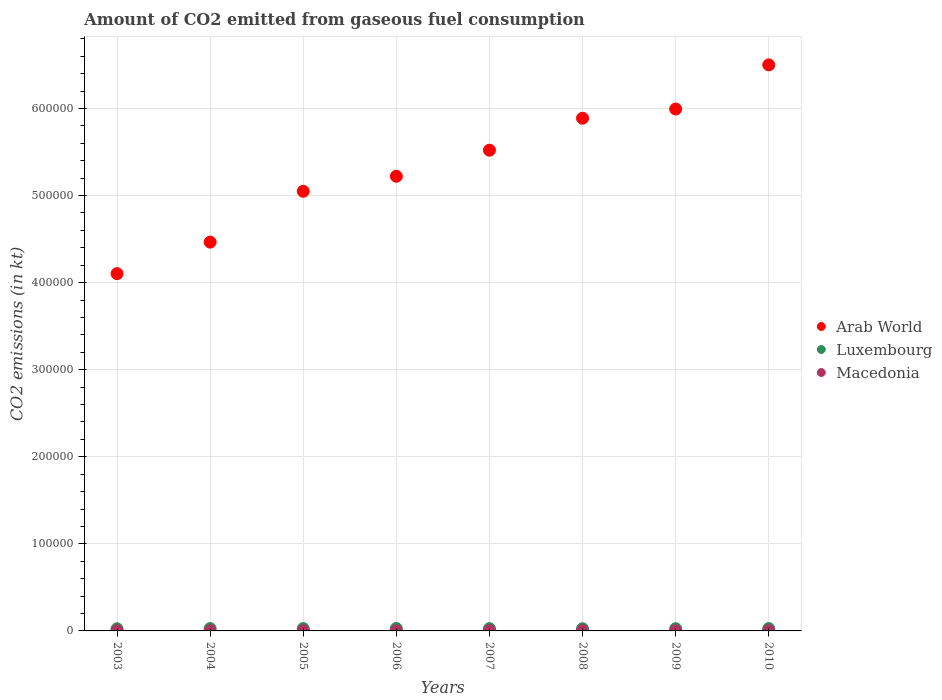How many different coloured dotlines are there?
Provide a succinct answer. 3. Is the number of dotlines equal to the number of legend labels?
Give a very brief answer. Yes. What is the amount of CO2 emitted in Arab World in 2005?
Your answer should be very brief. 5.05e+05. Across all years, what is the maximum amount of CO2 emitted in Arab World?
Your response must be concise. 6.50e+05. Across all years, what is the minimum amount of CO2 emitted in Arab World?
Keep it short and to the point. 4.10e+05. In which year was the amount of CO2 emitted in Arab World maximum?
Your answer should be very brief. 2010. What is the total amount of CO2 emitted in Arab World in the graph?
Your answer should be compact. 4.27e+06. What is the difference between the amount of CO2 emitted in Macedonia in 2006 and that in 2009?
Give a very brief answer. 7.33. What is the difference between the amount of CO2 emitted in Luxembourg in 2006 and the amount of CO2 emitted in Arab World in 2007?
Offer a terse response. -5.49e+05. What is the average amount of CO2 emitted in Arab World per year?
Keep it short and to the point. 5.34e+05. In the year 2003, what is the difference between the amount of CO2 emitted in Macedonia and amount of CO2 emitted in Luxembourg?
Give a very brief answer. -2321.21. What is the ratio of the amount of CO2 emitted in Luxembourg in 2003 to that in 2010?
Give a very brief answer. 0.9. Is the difference between the amount of CO2 emitted in Macedonia in 2004 and 2006 greater than the difference between the amount of CO2 emitted in Luxembourg in 2004 and 2006?
Make the answer very short. Yes. What is the difference between the highest and the second highest amount of CO2 emitted in Luxembourg?
Keep it short and to the point. 77.01. What is the difference between the highest and the lowest amount of CO2 emitted in Macedonia?
Provide a short and direct response. 88.01. In how many years, is the amount of CO2 emitted in Luxembourg greater than the average amount of CO2 emitted in Luxembourg taken over all years?
Ensure brevity in your answer.  4. Is it the case that in every year, the sum of the amount of CO2 emitted in Arab World and amount of CO2 emitted in Macedonia  is greater than the amount of CO2 emitted in Luxembourg?
Your response must be concise. Yes. Does the graph contain any zero values?
Offer a very short reply. No. Where does the legend appear in the graph?
Offer a terse response. Center right. What is the title of the graph?
Make the answer very short. Amount of CO2 emitted from gaseous fuel consumption. What is the label or title of the Y-axis?
Provide a short and direct response. CO2 emissions (in kt). What is the CO2 emissions (in kt) in Arab World in 2003?
Make the answer very short. 4.10e+05. What is the CO2 emissions (in kt) of Luxembourg in 2003?
Give a very brief answer. 2471.56. What is the CO2 emissions (in kt) in Macedonia in 2003?
Provide a succinct answer. 150.35. What is the CO2 emissions (in kt) in Arab World in 2004?
Give a very brief answer. 4.47e+05. What is the CO2 emissions (in kt) of Luxembourg in 2004?
Give a very brief answer. 2739.25. What is the CO2 emissions (in kt) of Macedonia in 2004?
Your answer should be very brief. 135.68. What is the CO2 emissions (in kt) in Arab World in 2005?
Provide a succinct answer. 5.05e+05. What is the CO2 emissions (in kt) in Luxembourg in 2005?
Ensure brevity in your answer.  2695.24. What is the CO2 emissions (in kt) of Macedonia in 2005?
Your answer should be compact. 143.01. What is the CO2 emissions (in kt) of Arab World in 2006?
Your answer should be compact. 5.22e+05. What is the CO2 emissions (in kt) of Luxembourg in 2006?
Your answer should be very brief. 2816.26. What is the CO2 emissions (in kt) of Macedonia in 2006?
Ensure brevity in your answer.  154.01. What is the CO2 emissions (in kt) in Arab World in 2007?
Offer a very short reply. 5.52e+05. What is the CO2 emissions (in kt) in Luxembourg in 2007?
Provide a short and direct response. 2629.24. What is the CO2 emissions (in kt) of Macedonia in 2007?
Ensure brevity in your answer.  194.35. What is the CO2 emissions (in kt) of Arab World in 2008?
Provide a succinct answer. 5.89e+05. What is the CO2 emissions (in kt) in Luxembourg in 2008?
Keep it short and to the point. 2504.56. What is the CO2 emissions (in kt) of Macedonia in 2008?
Give a very brief answer. 223.69. What is the CO2 emissions (in kt) in Arab World in 2009?
Your response must be concise. 5.99e+05. What is the CO2 emissions (in kt) of Luxembourg in 2009?
Make the answer very short. 2548.57. What is the CO2 emissions (in kt) in Macedonia in 2009?
Your response must be concise. 146.68. What is the CO2 emissions (in kt) in Arab World in 2010?
Offer a terse response. 6.50e+05. What is the CO2 emissions (in kt) in Luxembourg in 2010?
Provide a succinct answer. 2739.25. What is the CO2 emissions (in kt) in Macedonia in 2010?
Provide a short and direct response. 220.02. Across all years, what is the maximum CO2 emissions (in kt) in Arab World?
Your response must be concise. 6.50e+05. Across all years, what is the maximum CO2 emissions (in kt) of Luxembourg?
Your answer should be very brief. 2816.26. Across all years, what is the maximum CO2 emissions (in kt) in Macedonia?
Your answer should be very brief. 223.69. Across all years, what is the minimum CO2 emissions (in kt) of Arab World?
Give a very brief answer. 4.10e+05. Across all years, what is the minimum CO2 emissions (in kt) in Luxembourg?
Offer a terse response. 2471.56. Across all years, what is the minimum CO2 emissions (in kt) of Macedonia?
Make the answer very short. 135.68. What is the total CO2 emissions (in kt) of Arab World in the graph?
Offer a terse response. 4.27e+06. What is the total CO2 emissions (in kt) of Luxembourg in the graph?
Your response must be concise. 2.11e+04. What is the total CO2 emissions (in kt) of Macedonia in the graph?
Your response must be concise. 1367.79. What is the difference between the CO2 emissions (in kt) in Arab World in 2003 and that in 2004?
Ensure brevity in your answer.  -3.62e+04. What is the difference between the CO2 emissions (in kt) of Luxembourg in 2003 and that in 2004?
Keep it short and to the point. -267.69. What is the difference between the CO2 emissions (in kt) in Macedonia in 2003 and that in 2004?
Keep it short and to the point. 14.67. What is the difference between the CO2 emissions (in kt) of Arab World in 2003 and that in 2005?
Provide a short and direct response. -9.46e+04. What is the difference between the CO2 emissions (in kt) in Luxembourg in 2003 and that in 2005?
Your answer should be very brief. -223.69. What is the difference between the CO2 emissions (in kt) in Macedonia in 2003 and that in 2005?
Offer a terse response. 7.33. What is the difference between the CO2 emissions (in kt) of Arab World in 2003 and that in 2006?
Your answer should be compact. -1.12e+05. What is the difference between the CO2 emissions (in kt) of Luxembourg in 2003 and that in 2006?
Make the answer very short. -344.7. What is the difference between the CO2 emissions (in kt) in Macedonia in 2003 and that in 2006?
Keep it short and to the point. -3.67. What is the difference between the CO2 emissions (in kt) in Arab World in 2003 and that in 2007?
Your response must be concise. -1.42e+05. What is the difference between the CO2 emissions (in kt) in Luxembourg in 2003 and that in 2007?
Offer a terse response. -157.68. What is the difference between the CO2 emissions (in kt) of Macedonia in 2003 and that in 2007?
Give a very brief answer. -44. What is the difference between the CO2 emissions (in kt) in Arab World in 2003 and that in 2008?
Ensure brevity in your answer.  -1.78e+05. What is the difference between the CO2 emissions (in kt) in Luxembourg in 2003 and that in 2008?
Give a very brief answer. -33. What is the difference between the CO2 emissions (in kt) of Macedonia in 2003 and that in 2008?
Ensure brevity in your answer.  -73.34. What is the difference between the CO2 emissions (in kt) in Arab World in 2003 and that in 2009?
Give a very brief answer. -1.89e+05. What is the difference between the CO2 emissions (in kt) in Luxembourg in 2003 and that in 2009?
Your answer should be compact. -77.01. What is the difference between the CO2 emissions (in kt) in Macedonia in 2003 and that in 2009?
Make the answer very short. 3.67. What is the difference between the CO2 emissions (in kt) of Arab World in 2003 and that in 2010?
Make the answer very short. -2.40e+05. What is the difference between the CO2 emissions (in kt) of Luxembourg in 2003 and that in 2010?
Keep it short and to the point. -267.69. What is the difference between the CO2 emissions (in kt) of Macedonia in 2003 and that in 2010?
Your answer should be very brief. -69.67. What is the difference between the CO2 emissions (in kt) of Arab World in 2004 and that in 2005?
Offer a terse response. -5.84e+04. What is the difference between the CO2 emissions (in kt) of Luxembourg in 2004 and that in 2005?
Provide a short and direct response. 44. What is the difference between the CO2 emissions (in kt) in Macedonia in 2004 and that in 2005?
Provide a succinct answer. -7.33. What is the difference between the CO2 emissions (in kt) of Arab World in 2004 and that in 2006?
Provide a succinct answer. -7.56e+04. What is the difference between the CO2 emissions (in kt) of Luxembourg in 2004 and that in 2006?
Your answer should be very brief. -77.01. What is the difference between the CO2 emissions (in kt) of Macedonia in 2004 and that in 2006?
Keep it short and to the point. -18.34. What is the difference between the CO2 emissions (in kt) in Arab World in 2004 and that in 2007?
Ensure brevity in your answer.  -1.06e+05. What is the difference between the CO2 emissions (in kt) of Luxembourg in 2004 and that in 2007?
Provide a short and direct response. 110.01. What is the difference between the CO2 emissions (in kt) of Macedonia in 2004 and that in 2007?
Give a very brief answer. -58.67. What is the difference between the CO2 emissions (in kt) of Arab World in 2004 and that in 2008?
Your answer should be very brief. -1.42e+05. What is the difference between the CO2 emissions (in kt) of Luxembourg in 2004 and that in 2008?
Your response must be concise. 234.69. What is the difference between the CO2 emissions (in kt) of Macedonia in 2004 and that in 2008?
Give a very brief answer. -88.01. What is the difference between the CO2 emissions (in kt) in Arab World in 2004 and that in 2009?
Make the answer very short. -1.53e+05. What is the difference between the CO2 emissions (in kt) in Luxembourg in 2004 and that in 2009?
Provide a succinct answer. 190.68. What is the difference between the CO2 emissions (in kt) of Macedonia in 2004 and that in 2009?
Make the answer very short. -11. What is the difference between the CO2 emissions (in kt) in Arab World in 2004 and that in 2010?
Keep it short and to the point. -2.04e+05. What is the difference between the CO2 emissions (in kt) of Luxembourg in 2004 and that in 2010?
Keep it short and to the point. 0. What is the difference between the CO2 emissions (in kt) of Macedonia in 2004 and that in 2010?
Offer a very short reply. -84.34. What is the difference between the CO2 emissions (in kt) in Arab World in 2005 and that in 2006?
Your answer should be compact. -1.72e+04. What is the difference between the CO2 emissions (in kt) in Luxembourg in 2005 and that in 2006?
Offer a very short reply. -121.01. What is the difference between the CO2 emissions (in kt) in Macedonia in 2005 and that in 2006?
Your answer should be compact. -11. What is the difference between the CO2 emissions (in kt) in Arab World in 2005 and that in 2007?
Offer a very short reply. -4.72e+04. What is the difference between the CO2 emissions (in kt) of Luxembourg in 2005 and that in 2007?
Your answer should be compact. 66.01. What is the difference between the CO2 emissions (in kt) of Macedonia in 2005 and that in 2007?
Provide a succinct answer. -51.34. What is the difference between the CO2 emissions (in kt) of Arab World in 2005 and that in 2008?
Your answer should be very brief. -8.39e+04. What is the difference between the CO2 emissions (in kt) in Luxembourg in 2005 and that in 2008?
Provide a succinct answer. 190.68. What is the difference between the CO2 emissions (in kt) of Macedonia in 2005 and that in 2008?
Your answer should be very brief. -80.67. What is the difference between the CO2 emissions (in kt) of Arab World in 2005 and that in 2009?
Your answer should be compact. -9.45e+04. What is the difference between the CO2 emissions (in kt) in Luxembourg in 2005 and that in 2009?
Provide a succinct answer. 146.68. What is the difference between the CO2 emissions (in kt) of Macedonia in 2005 and that in 2009?
Keep it short and to the point. -3.67. What is the difference between the CO2 emissions (in kt) in Arab World in 2005 and that in 2010?
Give a very brief answer. -1.45e+05. What is the difference between the CO2 emissions (in kt) in Luxembourg in 2005 and that in 2010?
Make the answer very short. -44. What is the difference between the CO2 emissions (in kt) in Macedonia in 2005 and that in 2010?
Provide a short and direct response. -77.01. What is the difference between the CO2 emissions (in kt) of Arab World in 2006 and that in 2007?
Your answer should be compact. -2.99e+04. What is the difference between the CO2 emissions (in kt) in Luxembourg in 2006 and that in 2007?
Provide a short and direct response. 187.02. What is the difference between the CO2 emissions (in kt) of Macedonia in 2006 and that in 2007?
Your response must be concise. -40.34. What is the difference between the CO2 emissions (in kt) in Arab World in 2006 and that in 2008?
Keep it short and to the point. -6.67e+04. What is the difference between the CO2 emissions (in kt) of Luxembourg in 2006 and that in 2008?
Keep it short and to the point. 311.69. What is the difference between the CO2 emissions (in kt) of Macedonia in 2006 and that in 2008?
Your answer should be very brief. -69.67. What is the difference between the CO2 emissions (in kt) of Arab World in 2006 and that in 2009?
Your answer should be very brief. -7.72e+04. What is the difference between the CO2 emissions (in kt) in Luxembourg in 2006 and that in 2009?
Give a very brief answer. 267.69. What is the difference between the CO2 emissions (in kt) in Macedonia in 2006 and that in 2009?
Offer a very short reply. 7.33. What is the difference between the CO2 emissions (in kt) of Arab World in 2006 and that in 2010?
Provide a short and direct response. -1.28e+05. What is the difference between the CO2 emissions (in kt) in Luxembourg in 2006 and that in 2010?
Offer a terse response. 77.01. What is the difference between the CO2 emissions (in kt) in Macedonia in 2006 and that in 2010?
Offer a very short reply. -66.01. What is the difference between the CO2 emissions (in kt) in Arab World in 2007 and that in 2008?
Offer a terse response. -3.67e+04. What is the difference between the CO2 emissions (in kt) of Luxembourg in 2007 and that in 2008?
Provide a short and direct response. 124.68. What is the difference between the CO2 emissions (in kt) of Macedonia in 2007 and that in 2008?
Your response must be concise. -29.34. What is the difference between the CO2 emissions (in kt) in Arab World in 2007 and that in 2009?
Give a very brief answer. -4.73e+04. What is the difference between the CO2 emissions (in kt) in Luxembourg in 2007 and that in 2009?
Your response must be concise. 80.67. What is the difference between the CO2 emissions (in kt) of Macedonia in 2007 and that in 2009?
Offer a very short reply. 47.67. What is the difference between the CO2 emissions (in kt) in Arab World in 2007 and that in 2010?
Keep it short and to the point. -9.80e+04. What is the difference between the CO2 emissions (in kt) in Luxembourg in 2007 and that in 2010?
Keep it short and to the point. -110.01. What is the difference between the CO2 emissions (in kt) of Macedonia in 2007 and that in 2010?
Ensure brevity in your answer.  -25.67. What is the difference between the CO2 emissions (in kt) of Arab World in 2008 and that in 2009?
Ensure brevity in your answer.  -1.06e+04. What is the difference between the CO2 emissions (in kt) of Luxembourg in 2008 and that in 2009?
Provide a short and direct response. -44. What is the difference between the CO2 emissions (in kt) of Macedonia in 2008 and that in 2009?
Your answer should be very brief. 77.01. What is the difference between the CO2 emissions (in kt) in Arab World in 2008 and that in 2010?
Your answer should be very brief. -6.13e+04. What is the difference between the CO2 emissions (in kt) of Luxembourg in 2008 and that in 2010?
Provide a short and direct response. -234.69. What is the difference between the CO2 emissions (in kt) in Macedonia in 2008 and that in 2010?
Provide a short and direct response. 3.67. What is the difference between the CO2 emissions (in kt) of Arab World in 2009 and that in 2010?
Your response must be concise. -5.07e+04. What is the difference between the CO2 emissions (in kt) in Luxembourg in 2009 and that in 2010?
Your response must be concise. -190.68. What is the difference between the CO2 emissions (in kt) in Macedonia in 2009 and that in 2010?
Your answer should be compact. -73.34. What is the difference between the CO2 emissions (in kt) in Arab World in 2003 and the CO2 emissions (in kt) in Luxembourg in 2004?
Provide a short and direct response. 4.08e+05. What is the difference between the CO2 emissions (in kt) in Arab World in 2003 and the CO2 emissions (in kt) in Macedonia in 2004?
Offer a terse response. 4.10e+05. What is the difference between the CO2 emissions (in kt) in Luxembourg in 2003 and the CO2 emissions (in kt) in Macedonia in 2004?
Ensure brevity in your answer.  2335.88. What is the difference between the CO2 emissions (in kt) of Arab World in 2003 and the CO2 emissions (in kt) of Luxembourg in 2005?
Keep it short and to the point. 4.08e+05. What is the difference between the CO2 emissions (in kt) of Arab World in 2003 and the CO2 emissions (in kt) of Macedonia in 2005?
Provide a succinct answer. 4.10e+05. What is the difference between the CO2 emissions (in kt) in Luxembourg in 2003 and the CO2 emissions (in kt) in Macedonia in 2005?
Your answer should be very brief. 2328.55. What is the difference between the CO2 emissions (in kt) of Arab World in 2003 and the CO2 emissions (in kt) of Luxembourg in 2006?
Provide a succinct answer. 4.07e+05. What is the difference between the CO2 emissions (in kt) in Arab World in 2003 and the CO2 emissions (in kt) in Macedonia in 2006?
Make the answer very short. 4.10e+05. What is the difference between the CO2 emissions (in kt) of Luxembourg in 2003 and the CO2 emissions (in kt) of Macedonia in 2006?
Your response must be concise. 2317.54. What is the difference between the CO2 emissions (in kt) in Arab World in 2003 and the CO2 emissions (in kt) in Luxembourg in 2007?
Provide a succinct answer. 4.08e+05. What is the difference between the CO2 emissions (in kt) in Arab World in 2003 and the CO2 emissions (in kt) in Macedonia in 2007?
Give a very brief answer. 4.10e+05. What is the difference between the CO2 emissions (in kt) of Luxembourg in 2003 and the CO2 emissions (in kt) of Macedonia in 2007?
Make the answer very short. 2277.21. What is the difference between the CO2 emissions (in kt) of Arab World in 2003 and the CO2 emissions (in kt) of Luxembourg in 2008?
Your response must be concise. 4.08e+05. What is the difference between the CO2 emissions (in kt) in Arab World in 2003 and the CO2 emissions (in kt) in Macedonia in 2008?
Keep it short and to the point. 4.10e+05. What is the difference between the CO2 emissions (in kt) in Luxembourg in 2003 and the CO2 emissions (in kt) in Macedonia in 2008?
Your answer should be very brief. 2247.87. What is the difference between the CO2 emissions (in kt) in Arab World in 2003 and the CO2 emissions (in kt) in Luxembourg in 2009?
Keep it short and to the point. 4.08e+05. What is the difference between the CO2 emissions (in kt) of Arab World in 2003 and the CO2 emissions (in kt) of Macedonia in 2009?
Offer a terse response. 4.10e+05. What is the difference between the CO2 emissions (in kt) in Luxembourg in 2003 and the CO2 emissions (in kt) in Macedonia in 2009?
Your answer should be compact. 2324.88. What is the difference between the CO2 emissions (in kt) of Arab World in 2003 and the CO2 emissions (in kt) of Luxembourg in 2010?
Offer a very short reply. 4.08e+05. What is the difference between the CO2 emissions (in kt) in Arab World in 2003 and the CO2 emissions (in kt) in Macedonia in 2010?
Ensure brevity in your answer.  4.10e+05. What is the difference between the CO2 emissions (in kt) in Luxembourg in 2003 and the CO2 emissions (in kt) in Macedonia in 2010?
Offer a very short reply. 2251.54. What is the difference between the CO2 emissions (in kt) of Arab World in 2004 and the CO2 emissions (in kt) of Luxembourg in 2005?
Ensure brevity in your answer.  4.44e+05. What is the difference between the CO2 emissions (in kt) of Arab World in 2004 and the CO2 emissions (in kt) of Macedonia in 2005?
Give a very brief answer. 4.46e+05. What is the difference between the CO2 emissions (in kt) in Luxembourg in 2004 and the CO2 emissions (in kt) in Macedonia in 2005?
Offer a terse response. 2596.24. What is the difference between the CO2 emissions (in kt) of Arab World in 2004 and the CO2 emissions (in kt) of Luxembourg in 2006?
Your answer should be compact. 4.44e+05. What is the difference between the CO2 emissions (in kt) in Arab World in 2004 and the CO2 emissions (in kt) in Macedonia in 2006?
Keep it short and to the point. 4.46e+05. What is the difference between the CO2 emissions (in kt) in Luxembourg in 2004 and the CO2 emissions (in kt) in Macedonia in 2006?
Give a very brief answer. 2585.24. What is the difference between the CO2 emissions (in kt) of Arab World in 2004 and the CO2 emissions (in kt) of Luxembourg in 2007?
Your answer should be compact. 4.44e+05. What is the difference between the CO2 emissions (in kt) in Arab World in 2004 and the CO2 emissions (in kt) in Macedonia in 2007?
Ensure brevity in your answer.  4.46e+05. What is the difference between the CO2 emissions (in kt) in Luxembourg in 2004 and the CO2 emissions (in kt) in Macedonia in 2007?
Your response must be concise. 2544.9. What is the difference between the CO2 emissions (in kt) in Arab World in 2004 and the CO2 emissions (in kt) in Luxembourg in 2008?
Your response must be concise. 4.44e+05. What is the difference between the CO2 emissions (in kt) of Arab World in 2004 and the CO2 emissions (in kt) of Macedonia in 2008?
Give a very brief answer. 4.46e+05. What is the difference between the CO2 emissions (in kt) in Luxembourg in 2004 and the CO2 emissions (in kt) in Macedonia in 2008?
Your response must be concise. 2515.56. What is the difference between the CO2 emissions (in kt) in Arab World in 2004 and the CO2 emissions (in kt) in Luxembourg in 2009?
Your response must be concise. 4.44e+05. What is the difference between the CO2 emissions (in kt) of Arab World in 2004 and the CO2 emissions (in kt) of Macedonia in 2009?
Keep it short and to the point. 4.46e+05. What is the difference between the CO2 emissions (in kt) of Luxembourg in 2004 and the CO2 emissions (in kt) of Macedonia in 2009?
Offer a very short reply. 2592.57. What is the difference between the CO2 emissions (in kt) in Arab World in 2004 and the CO2 emissions (in kt) in Luxembourg in 2010?
Make the answer very short. 4.44e+05. What is the difference between the CO2 emissions (in kt) of Arab World in 2004 and the CO2 emissions (in kt) of Macedonia in 2010?
Your response must be concise. 4.46e+05. What is the difference between the CO2 emissions (in kt) of Luxembourg in 2004 and the CO2 emissions (in kt) of Macedonia in 2010?
Make the answer very short. 2519.23. What is the difference between the CO2 emissions (in kt) of Arab World in 2005 and the CO2 emissions (in kt) of Luxembourg in 2006?
Offer a very short reply. 5.02e+05. What is the difference between the CO2 emissions (in kt) of Arab World in 2005 and the CO2 emissions (in kt) of Macedonia in 2006?
Your response must be concise. 5.05e+05. What is the difference between the CO2 emissions (in kt) in Luxembourg in 2005 and the CO2 emissions (in kt) in Macedonia in 2006?
Keep it short and to the point. 2541.23. What is the difference between the CO2 emissions (in kt) of Arab World in 2005 and the CO2 emissions (in kt) of Luxembourg in 2007?
Make the answer very short. 5.02e+05. What is the difference between the CO2 emissions (in kt) in Arab World in 2005 and the CO2 emissions (in kt) in Macedonia in 2007?
Your answer should be very brief. 5.05e+05. What is the difference between the CO2 emissions (in kt) of Luxembourg in 2005 and the CO2 emissions (in kt) of Macedonia in 2007?
Provide a short and direct response. 2500.89. What is the difference between the CO2 emissions (in kt) of Arab World in 2005 and the CO2 emissions (in kt) of Luxembourg in 2008?
Offer a terse response. 5.02e+05. What is the difference between the CO2 emissions (in kt) of Arab World in 2005 and the CO2 emissions (in kt) of Macedonia in 2008?
Your response must be concise. 5.05e+05. What is the difference between the CO2 emissions (in kt) of Luxembourg in 2005 and the CO2 emissions (in kt) of Macedonia in 2008?
Offer a very short reply. 2471.56. What is the difference between the CO2 emissions (in kt) of Arab World in 2005 and the CO2 emissions (in kt) of Luxembourg in 2009?
Provide a succinct answer. 5.02e+05. What is the difference between the CO2 emissions (in kt) in Arab World in 2005 and the CO2 emissions (in kt) in Macedonia in 2009?
Offer a terse response. 5.05e+05. What is the difference between the CO2 emissions (in kt) in Luxembourg in 2005 and the CO2 emissions (in kt) in Macedonia in 2009?
Provide a succinct answer. 2548.57. What is the difference between the CO2 emissions (in kt) of Arab World in 2005 and the CO2 emissions (in kt) of Luxembourg in 2010?
Offer a terse response. 5.02e+05. What is the difference between the CO2 emissions (in kt) in Arab World in 2005 and the CO2 emissions (in kt) in Macedonia in 2010?
Give a very brief answer. 5.05e+05. What is the difference between the CO2 emissions (in kt) in Luxembourg in 2005 and the CO2 emissions (in kt) in Macedonia in 2010?
Offer a terse response. 2475.22. What is the difference between the CO2 emissions (in kt) of Arab World in 2006 and the CO2 emissions (in kt) of Luxembourg in 2007?
Provide a succinct answer. 5.19e+05. What is the difference between the CO2 emissions (in kt) of Arab World in 2006 and the CO2 emissions (in kt) of Macedonia in 2007?
Give a very brief answer. 5.22e+05. What is the difference between the CO2 emissions (in kt) of Luxembourg in 2006 and the CO2 emissions (in kt) of Macedonia in 2007?
Your answer should be compact. 2621.91. What is the difference between the CO2 emissions (in kt) of Arab World in 2006 and the CO2 emissions (in kt) of Luxembourg in 2008?
Ensure brevity in your answer.  5.20e+05. What is the difference between the CO2 emissions (in kt) in Arab World in 2006 and the CO2 emissions (in kt) in Macedonia in 2008?
Ensure brevity in your answer.  5.22e+05. What is the difference between the CO2 emissions (in kt) of Luxembourg in 2006 and the CO2 emissions (in kt) of Macedonia in 2008?
Offer a very short reply. 2592.57. What is the difference between the CO2 emissions (in kt) of Arab World in 2006 and the CO2 emissions (in kt) of Luxembourg in 2009?
Make the answer very short. 5.20e+05. What is the difference between the CO2 emissions (in kt) in Arab World in 2006 and the CO2 emissions (in kt) in Macedonia in 2009?
Provide a short and direct response. 5.22e+05. What is the difference between the CO2 emissions (in kt) in Luxembourg in 2006 and the CO2 emissions (in kt) in Macedonia in 2009?
Your answer should be compact. 2669.58. What is the difference between the CO2 emissions (in kt) in Arab World in 2006 and the CO2 emissions (in kt) in Luxembourg in 2010?
Provide a short and direct response. 5.19e+05. What is the difference between the CO2 emissions (in kt) in Arab World in 2006 and the CO2 emissions (in kt) in Macedonia in 2010?
Your response must be concise. 5.22e+05. What is the difference between the CO2 emissions (in kt) in Luxembourg in 2006 and the CO2 emissions (in kt) in Macedonia in 2010?
Give a very brief answer. 2596.24. What is the difference between the CO2 emissions (in kt) in Arab World in 2007 and the CO2 emissions (in kt) in Luxembourg in 2008?
Your answer should be compact. 5.50e+05. What is the difference between the CO2 emissions (in kt) in Arab World in 2007 and the CO2 emissions (in kt) in Macedonia in 2008?
Offer a terse response. 5.52e+05. What is the difference between the CO2 emissions (in kt) in Luxembourg in 2007 and the CO2 emissions (in kt) in Macedonia in 2008?
Your response must be concise. 2405.55. What is the difference between the CO2 emissions (in kt) of Arab World in 2007 and the CO2 emissions (in kt) of Luxembourg in 2009?
Your response must be concise. 5.50e+05. What is the difference between the CO2 emissions (in kt) of Arab World in 2007 and the CO2 emissions (in kt) of Macedonia in 2009?
Your response must be concise. 5.52e+05. What is the difference between the CO2 emissions (in kt) in Luxembourg in 2007 and the CO2 emissions (in kt) in Macedonia in 2009?
Provide a succinct answer. 2482.56. What is the difference between the CO2 emissions (in kt) of Arab World in 2007 and the CO2 emissions (in kt) of Luxembourg in 2010?
Your answer should be compact. 5.49e+05. What is the difference between the CO2 emissions (in kt) in Arab World in 2007 and the CO2 emissions (in kt) in Macedonia in 2010?
Provide a short and direct response. 5.52e+05. What is the difference between the CO2 emissions (in kt) of Luxembourg in 2007 and the CO2 emissions (in kt) of Macedonia in 2010?
Keep it short and to the point. 2409.22. What is the difference between the CO2 emissions (in kt) of Arab World in 2008 and the CO2 emissions (in kt) of Luxembourg in 2009?
Your answer should be compact. 5.86e+05. What is the difference between the CO2 emissions (in kt) of Arab World in 2008 and the CO2 emissions (in kt) of Macedonia in 2009?
Your answer should be compact. 5.89e+05. What is the difference between the CO2 emissions (in kt) in Luxembourg in 2008 and the CO2 emissions (in kt) in Macedonia in 2009?
Your answer should be compact. 2357.88. What is the difference between the CO2 emissions (in kt) of Arab World in 2008 and the CO2 emissions (in kt) of Luxembourg in 2010?
Your response must be concise. 5.86e+05. What is the difference between the CO2 emissions (in kt) of Arab World in 2008 and the CO2 emissions (in kt) of Macedonia in 2010?
Offer a very short reply. 5.89e+05. What is the difference between the CO2 emissions (in kt) in Luxembourg in 2008 and the CO2 emissions (in kt) in Macedonia in 2010?
Your answer should be very brief. 2284.54. What is the difference between the CO2 emissions (in kt) in Arab World in 2009 and the CO2 emissions (in kt) in Luxembourg in 2010?
Your answer should be very brief. 5.97e+05. What is the difference between the CO2 emissions (in kt) of Arab World in 2009 and the CO2 emissions (in kt) of Macedonia in 2010?
Give a very brief answer. 5.99e+05. What is the difference between the CO2 emissions (in kt) in Luxembourg in 2009 and the CO2 emissions (in kt) in Macedonia in 2010?
Ensure brevity in your answer.  2328.55. What is the average CO2 emissions (in kt) in Arab World per year?
Keep it short and to the point. 5.34e+05. What is the average CO2 emissions (in kt) of Luxembourg per year?
Your response must be concise. 2642.99. What is the average CO2 emissions (in kt) in Macedonia per year?
Offer a very short reply. 170.97. In the year 2003, what is the difference between the CO2 emissions (in kt) in Arab World and CO2 emissions (in kt) in Luxembourg?
Offer a terse response. 4.08e+05. In the year 2003, what is the difference between the CO2 emissions (in kt) in Arab World and CO2 emissions (in kt) in Macedonia?
Provide a succinct answer. 4.10e+05. In the year 2003, what is the difference between the CO2 emissions (in kt) in Luxembourg and CO2 emissions (in kt) in Macedonia?
Your response must be concise. 2321.21. In the year 2004, what is the difference between the CO2 emissions (in kt) of Arab World and CO2 emissions (in kt) of Luxembourg?
Your answer should be compact. 4.44e+05. In the year 2004, what is the difference between the CO2 emissions (in kt) in Arab World and CO2 emissions (in kt) in Macedonia?
Your answer should be compact. 4.46e+05. In the year 2004, what is the difference between the CO2 emissions (in kt) in Luxembourg and CO2 emissions (in kt) in Macedonia?
Your response must be concise. 2603.57. In the year 2005, what is the difference between the CO2 emissions (in kt) in Arab World and CO2 emissions (in kt) in Luxembourg?
Keep it short and to the point. 5.02e+05. In the year 2005, what is the difference between the CO2 emissions (in kt) in Arab World and CO2 emissions (in kt) in Macedonia?
Offer a very short reply. 5.05e+05. In the year 2005, what is the difference between the CO2 emissions (in kt) in Luxembourg and CO2 emissions (in kt) in Macedonia?
Provide a short and direct response. 2552.23. In the year 2006, what is the difference between the CO2 emissions (in kt) of Arab World and CO2 emissions (in kt) of Luxembourg?
Give a very brief answer. 5.19e+05. In the year 2006, what is the difference between the CO2 emissions (in kt) of Arab World and CO2 emissions (in kt) of Macedonia?
Keep it short and to the point. 5.22e+05. In the year 2006, what is the difference between the CO2 emissions (in kt) in Luxembourg and CO2 emissions (in kt) in Macedonia?
Your answer should be compact. 2662.24. In the year 2007, what is the difference between the CO2 emissions (in kt) of Arab World and CO2 emissions (in kt) of Luxembourg?
Give a very brief answer. 5.49e+05. In the year 2007, what is the difference between the CO2 emissions (in kt) of Arab World and CO2 emissions (in kt) of Macedonia?
Ensure brevity in your answer.  5.52e+05. In the year 2007, what is the difference between the CO2 emissions (in kt) of Luxembourg and CO2 emissions (in kt) of Macedonia?
Offer a terse response. 2434.89. In the year 2008, what is the difference between the CO2 emissions (in kt) of Arab World and CO2 emissions (in kt) of Luxembourg?
Provide a succinct answer. 5.86e+05. In the year 2008, what is the difference between the CO2 emissions (in kt) in Arab World and CO2 emissions (in kt) in Macedonia?
Offer a terse response. 5.89e+05. In the year 2008, what is the difference between the CO2 emissions (in kt) in Luxembourg and CO2 emissions (in kt) in Macedonia?
Your answer should be very brief. 2280.87. In the year 2009, what is the difference between the CO2 emissions (in kt) of Arab World and CO2 emissions (in kt) of Luxembourg?
Ensure brevity in your answer.  5.97e+05. In the year 2009, what is the difference between the CO2 emissions (in kt) of Arab World and CO2 emissions (in kt) of Macedonia?
Give a very brief answer. 5.99e+05. In the year 2009, what is the difference between the CO2 emissions (in kt) of Luxembourg and CO2 emissions (in kt) of Macedonia?
Offer a terse response. 2401.89. In the year 2010, what is the difference between the CO2 emissions (in kt) in Arab World and CO2 emissions (in kt) in Luxembourg?
Keep it short and to the point. 6.47e+05. In the year 2010, what is the difference between the CO2 emissions (in kt) in Arab World and CO2 emissions (in kt) in Macedonia?
Your answer should be very brief. 6.50e+05. In the year 2010, what is the difference between the CO2 emissions (in kt) in Luxembourg and CO2 emissions (in kt) in Macedonia?
Your answer should be compact. 2519.23. What is the ratio of the CO2 emissions (in kt) in Arab World in 2003 to that in 2004?
Keep it short and to the point. 0.92. What is the ratio of the CO2 emissions (in kt) of Luxembourg in 2003 to that in 2004?
Offer a very short reply. 0.9. What is the ratio of the CO2 emissions (in kt) in Macedonia in 2003 to that in 2004?
Ensure brevity in your answer.  1.11. What is the ratio of the CO2 emissions (in kt) of Arab World in 2003 to that in 2005?
Provide a succinct answer. 0.81. What is the ratio of the CO2 emissions (in kt) in Luxembourg in 2003 to that in 2005?
Your answer should be very brief. 0.92. What is the ratio of the CO2 emissions (in kt) in Macedonia in 2003 to that in 2005?
Make the answer very short. 1.05. What is the ratio of the CO2 emissions (in kt) of Arab World in 2003 to that in 2006?
Give a very brief answer. 0.79. What is the ratio of the CO2 emissions (in kt) in Luxembourg in 2003 to that in 2006?
Give a very brief answer. 0.88. What is the ratio of the CO2 emissions (in kt) of Macedonia in 2003 to that in 2006?
Ensure brevity in your answer.  0.98. What is the ratio of the CO2 emissions (in kt) of Arab World in 2003 to that in 2007?
Make the answer very short. 0.74. What is the ratio of the CO2 emissions (in kt) in Macedonia in 2003 to that in 2007?
Make the answer very short. 0.77. What is the ratio of the CO2 emissions (in kt) of Arab World in 2003 to that in 2008?
Your answer should be very brief. 0.7. What is the ratio of the CO2 emissions (in kt) in Macedonia in 2003 to that in 2008?
Your answer should be compact. 0.67. What is the ratio of the CO2 emissions (in kt) of Arab World in 2003 to that in 2009?
Your answer should be compact. 0.68. What is the ratio of the CO2 emissions (in kt) in Luxembourg in 2003 to that in 2009?
Make the answer very short. 0.97. What is the ratio of the CO2 emissions (in kt) of Macedonia in 2003 to that in 2009?
Your answer should be compact. 1.02. What is the ratio of the CO2 emissions (in kt) of Arab World in 2003 to that in 2010?
Provide a succinct answer. 0.63. What is the ratio of the CO2 emissions (in kt) in Luxembourg in 2003 to that in 2010?
Offer a terse response. 0.9. What is the ratio of the CO2 emissions (in kt) in Macedonia in 2003 to that in 2010?
Provide a succinct answer. 0.68. What is the ratio of the CO2 emissions (in kt) in Arab World in 2004 to that in 2005?
Your answer should be compact. 0.88. What is the ratio of the CO2 emissions (in kt) of Luxembourg in 2004 to that in 2005?
Ensure brevity in your answer.  1.02. What is the ratio of the CO2 emissions (in kt) of Macedonia in 2004 to that in 2005?
Make the answer very short. 0.95. What is the ratio of the CO2 emissions (in kt) in Arab World in 2004 to that in 2006?
Your response must be concise. 0.86. What is the ratio of the CO2 emissions (in kt) of Luxembourg in 2004 to that in 2006?
Provide a succinct answer. 0.97. What is the ratio of the CO2 emissions (in kt) in Macedonia in 2004 to that in 2006?
Provide a short and direct response. 0.88. What is the ratio of the CO2 emissions (in kt) of Arab World in 2004 to that in 2007?
Offer a terse response. 0.81. What is the ratio of the CO2 emissions (in kt) in Luxembourg in 2004 to that in 2007?
Your answer should be very brief. 1.04. What is the ratio of the CO2 emissions (in kt) of Macedonia in 2004 to that in 2007?
Keep it short and to the point. 0.7. What is the ratio of the CO2 emissions (in kt) of Arab World in 2004 to that in 2008?
Keep it short and to the point. 0.76. What is the ratio of the CO2 emissions (in kt) of Luxembourg in 2004 to that in 2008?
Offer a terse response. 1.09. What is the ratio of the CO2 emissions (in kt) in Macedonia in 2004 to that in 2008?
Provide a short and direct response. 0.61. What is the ratio of the CO2 emissions (in kt) in Arab World in 2004 to that in 2009?
Give a very brief answer. 0.74. What is the ratio of the CO2 emissions (in kt) in Luxembourg in 2004 to that in 2009?
Your answer should be very brief. 1.07. What is the ratio of the CO2 emissions (in kt) of Macedonia in 2004 to that in 2009?
Your answer should be compact. 0.93. What is the ratio of the CO2 emissions (in kt) in Arab World in 2004 to that in 2010?
Provide a succinct answer. 0.69. What is the ratio of the CO2 emissions (in kt) of Luxembourg in 2004 to that in 2010?
Your answer should be compact. 1. What is the ratio of the CO2 emissions (in kt) of Macedonia in 2004 to that in 2010?
Your answer should be very brief. 0.62. What is the ratio of the CO2 emissions (in kt) in Arab World in 2005 to that in 2007?
Give a very brief answer. 0.91. What is the ratio of the CO2 emissions (in kt) of Luxembourg in 2005 to that in 2007?
Keep it short and to the point. 1.03. What is the ratio of the CO2 emissions (in kt) in Macedonia in 2005 to that in 2007?
Your answer should be compact. 0.74. What is the ratio of the CO2 emissions (in kt) in Arab World in 2005 to that in 2008?
Offer a terse response. 0.86. What is the ratio of the CO2 emissions (in kt) in Luxembourg in 2005 to that in 2008?
Offer a very short reply. 1.08. What is the ratio of the CO2 emissions (in kt) in Macedonia in 2005 to that in 2008?
Your answer should be compact. 0.64. What is the ratio of the CO2 emissions (in kt) in Arab World in 2005 to that in 2009?
Your answer should be very brief. 0.84. What is the ratio of the CO2 emissions (in kt) in Luxembourg in 2005 to that in 2009?
Your answer should be compact. 1.06. What is the ratio of the CO2 emissions (in kt) of Macedonia in 2005 to that in 2009?
Provide a succinct answer. 0.97. What is the ratio of the CO2 emissions (in kt) of Arab World in 2005 to that in 2010?
Make the answer very short. 0.78. What is the ratio of the CO2 emissions (in kt) of Luxembourg in 2005 to that in 2010?
Your answer should be very brief. 0.98. What is the ratio of the CO2 emissions (in kt) in Macedonia in 2005 to that in 2010?
Make the answer very short. 0.65. What is the ratio of the CO2 emissions (in kt) of Arab World in 2006 to that in 2007?
Offer a terse response. 0.95. What is the ratio of the CO2 emissions (in kt) of Luxembourg in 2006 to that in 2007?
Provide a succinct answer. 1.07. What is the ratio of the CO2 emissions (in kt) of Macedonia in 2006 to that in 2007?
Your response must be concise. 0.79. What is the ratio of the CO2 emissions (in kt) of Arab World in 2006 to that in 2008?
Make the answer very short. 0.89. What is the ratio of the CO2 emissions (in kt) in Luxembourg in 2006 to that in 2008?
Provide a short and direct response. 1.12. What is the ratio of the CO2 emissions (in kt) in Macedonia in 2006 to that in 2008?
Offer a terse response. 0.69. What is the ratio of the CO2 emissions (in kt) in Arab World in 2006 to that in 2009?
Make the answer very short. 0.87. What is the ratio of the CO2 emissions (in kt) in Luxembourg in 2006 to that in 2009?
Your response must be concise. 1.1. What is the ratio of the CO2 emissions (in kt) of Macedonia in 2006 to that in 2009?
Offer a very short reply. 1.05. What is the ratio of the CO2 emissions (in kt) in Arab World in 2006 to that in 2010?
Provide a succinct answer. 0.8. What is the ratio of the CO2 emissions (in kt) in Luxembourg in 2006 to that in 2010?
Provide a short and direct response. 1.03. What is the ratio of the CO2 emissions (in kt) of Macedonia in 2006 to that in 2010?
Offer a terse response. 0.7. What is the ratio of the CO2 emissions (in kt) of Arab World in 2007 to that in 2008?
Make the answer very short. 0.94. What is the ratio of the CO2 emissions (in kt) of Luxembourg in 2007 to that in 2008?
Provide a short and direct response. 1.05. What is the ratio of the CO2 emissions (in kt) of Macedonia in 2007 to that in 2008?
Your answer should be compact. 0.87. What is the ratio of the CO2 emissions (in kt) in Arab World in 2007 to that in 2009?
Offer a very short reply. 0.92. What is the ratio of the CO2 emissions (in kt) in Luxembourg in 2007 to that in 2009?
Make the answer very short. 1.03. What is the ratio of the CO2 emissions (in kt) of Macedonia in 2007 to that in 2009?
Offer a terse response. 1.32. What is the ratio of the CO2 emissions (in kt) of Arab World in 2007 to that in 2010?
Provide a short and direct response. 0.85. What is the ratio of the CO2 emissions (in kt) of Luxembourg in 2007 to that in 2010?
Provide a succinct answer. 0.96. What is the ratio of the CO2 emissions (in kt) in Macedonia in 2007 to that in 2010?
Ensure brevity in your answer.  0.88. What is the ratio of the CO2 emissions (in kt) in Arab World in 2008 to that in 2009?
Your answer should be very brief. 0.98. What is the ratio of the CO2 emissions (in kt) of Luxembourg in 2008 to that in 2009?
Your answer should be very brief. 0.98. What is the ratio of the CO2 emissions (in kt) in Macedonia in 2008 to that in 2009?
Your answer should be very brief. 1.52. What is the ratio of the CO2 emissions (in kt) in Arab World in 2008 to that in 2010?
Your answer should be very brief. 0.91. What is the ratio of the CO2 emissions (in kt) in Luxembourg in 2008 to that in 2010?
Your answer should be compact. 0.91. What is the ratio of the CO2 emissions (in kt) in Macedonia in 2008 to that in 2010?
Offer a terse response. 1.02. What is the ratio of the CO2 emissions (in kt) in Arab World in 2009 to that in 2010?
Give a very brief answer. 0.92. What is the ratio of the CO2 emissions (in kt) in Luxembourg in 2009 to that in 2010?
Your answer should be compact. 0.93. What is the ratio of the CO2 emissions (in kt) of Macedonia in 2009 to that in 2010?
Offer a terse response. 0.67. What is the difference between the highest and the second highest CO2 emissions (in kt) in Arab World?
Your answer should be very brief. 5.07e+04. What is the difference between the highest and the second highest CO2 emissions (in kt) in Luxembourg?
Your response must be concise. 77.01. What is the difference between the highest and the second highest CO2 emissions (in kt) in Macedonia?
Keep it short and to the point. 3.67. What is the difference between the highest and the lowest CO2 emissions (in kt) in Arab World?
Offer a terse response. 2.40e+05. What is the difference between the highest and the lowest CO2 emissions (in kt) in Luxembourg?
Provide a succinct answer. 344.7. What is the difference between the highest and the lowest CO2 emissions (in kt) in Macedonia?
Your answer should be very brief. 88.01. 